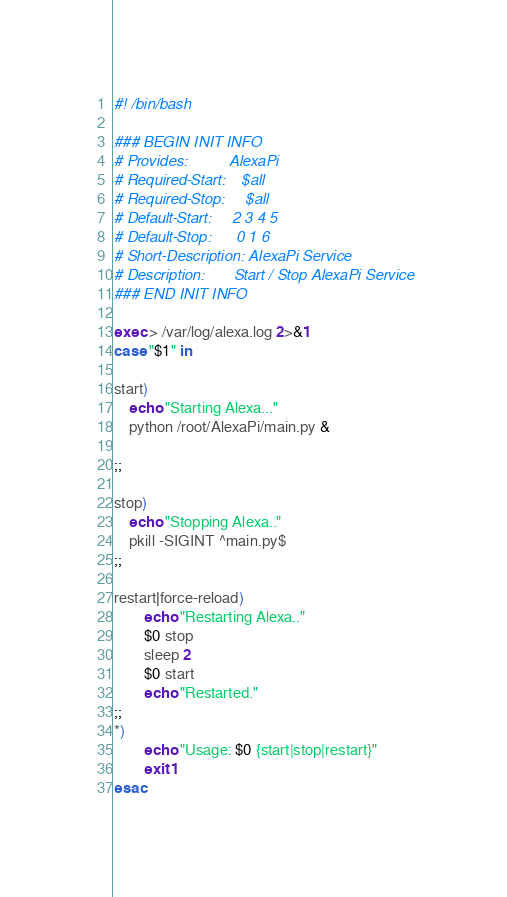<code> <loc_0><loc_0><loc_500><loc_500><_Bash_>#! /bin/bash

### BEGIN INIT INFO
# Provides:          AlexaPi
# Required-Start:    $all
# Required-Stop:     $all
# Default-Start:     2 3 4 5
# Default-Stop:      0 1 6
# Short-Description: AlexaPi Service
# Description:       Start / Stop AlexaPi Service
### END INIT INFO

exec > /var/log/alexa.log 2>&1 
case "$1" in

start)
    echo "Starting Alexa..."
    python /root/AlexaPi/main.py &

;;

stop)
    echo "Stopping Alexa.."
    pkill -SIGINT ^main.py$
;;

restart|force-reload)
        echo "Restarting Alexa.."
        $0 stop
        sleep 2
        $0 start
        echo "Restarted."
;;
*)
        echo "Usage: $0 {start|stop|restart}"
        exit 1
esac
</code> 